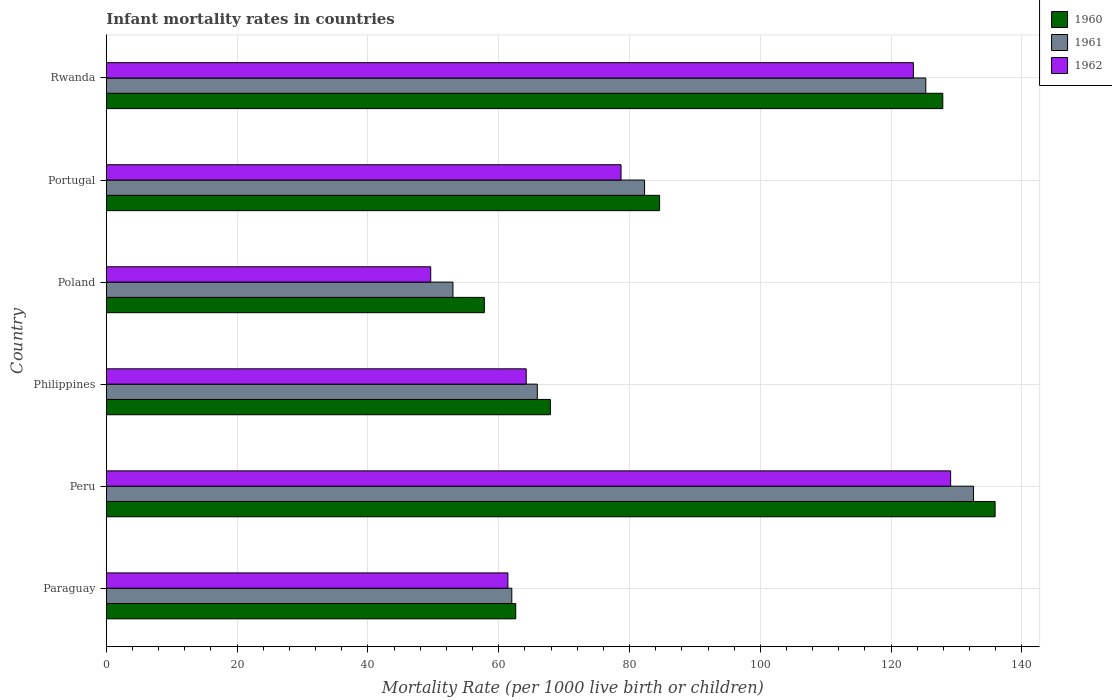How many different coloured bars are there?
Provide a short and direct response. 3. Are the number of bars per tick equal to the number of legend labels?
Offer a terse response. Yes. How many bars are there on the 2nd tick from the bottom?
Provide a succinct answer. 3. What is the infant mortality rate in 1960 in Philippines?
Your answer should be very brief. 67.9. Across all countries, what is the maximum infant mortality rate in 1962?
Make the answer very short. 129.1. Across all countries, what is the minimum infant mortality rate in 1960?
Give a very brief answer. 57.8. In which country was the infant mortality rate in 1962 maximum?
Make the answer very short. Peru. In which country was the infant mortality rate in 1962 minimum?
Provide a short and direct response. Poland. What is the total infant mortality rate in 1960 in the graph?
Provide a short and direct response. 536.7. What is the difference between the infant mortality rate in 1962 in Peru and that in Philippines?
Offer a terse response. 64.9. What is the difference between the infant mortality rate in 1961 in Poland and the infant mortality rate in 1962 in Portugal?
Keep it short and to the point. -25.7. What is the average infant mortality rate in 1960 per country?
Give a very brief answer. 89.45. What is the difference between the infant mortality rate in 1960 and infant mortality rate in 1961 in Paraguay?
Your response must be concise. 0.6. In how many countries, is the infant mortality rate in 1960 greater than 100 ?
Keep it short and to the point. 2. What is the ratio of the infant mortality rate in 1960 in Peru to that in Poland?
Your answer should be very brief. 2.35. Is the difference between the infant mortality rate in 1960 in Paraguay and Peru greater than the difference between the infant mortality rate in 1961 in Paraguay and Peru?
Your answer should be compact. No. What is the difference between the highest and the second highest infant mortality rate in 1961?
Give a very brief answer. 7.3. What is the difference between the highest and the lowest infant mortality rate in 1961?
Your answer should be compact. 79.6. Is the sum of the infant mortality rate in 1961 in Philippines and Poland greater than the maximum infant mortality rate in 1962 across all countries?
Give a very brief answer. No. What does the 1st bar from the bottom in Paraguay represents?
Your answer should be compact. 1960. Is it the case that in every country, the sum of the infant mortality rate in 1961 and infant mortality rate in 1962 is greater than the infant mortality rate in 1960?
Ensure brevity in your answer.  Yes. How many bars are there?
Ensure brevity in your answer.  18. Are all the bars in the graph horizontal?
Provide a succinct answer. Yes. How many countries are there in the graph?
Offer a terse response. 6. Are the values on the major ticks of X-axis written in scientific E-notation?
Provide a short and direct response. No. How are the legend labels stacked?
Your answer should be very brief. Vertical. What is the title of the graph?
Your answer should be very brief. Infant mortality rates in countries. What is the label or title of the X-axis?
Provide a succinct answer. Mortality Rate (per 1000 live birth or children). What is the Mortality Rate (per 1000 live birth or children) in 1960 in Paraguay?
Ensure brevity in your answer.  62.6. What is the Mortality Rate (per 1000 live birth or children) of 1962 in Paraguay?
Your response must be concise. 61.4. What is the Mortality Rate (per 1000 live birth or children) in 1960 in Peru?
Provide a short and direct response. 135.9. What is the Mortality Rate (per 1000 live birth or children) of 1961 in Peru?
Provide a succinct answer. 132.6. What is the Mortality Rate (per 1000 live birth or children) of 1962 in Peru?
Make the answer very short. 129.1. What is the Mortality Rate (per 1000 live birth or children) in 1960 in Philippines?
Your answer should be very brief. 67.9. What is the Mortality Rate (per 1000 live birth or children) of 1961 in Philippines?
Give a very brief answer. 65.9. What is the Mortality Rate (per 1000 live birth or children) in 1962 in Philippines?
Keep it short and to the point. 64.2. What is the Mortality Rate (per 1000 live birth or children) of 1960 in Poland?
Offer a very short reply. 57.8. What is the Mortality Rate (per 1000 live birth or children) in 1961 in Poland?
Your answer should be very brief. 53. What is the Mortality Rate (per 1000 live birth or children) of 1962 in Poland?
Provide a short and direct response. 49.6. What is the Mortality Rate (per 1000 live birth or children) of 1960 in Portugal?
Keep it short and to the point. 84.6. What is the Mortality Rate (per 1000 live birth or children) of 1961 in Portugal?
Give a very brief answer. 82.3. What is the Mortality Rate (per 1000 live birth or children) in 1962 in Portugal?
Your answer should be very brief. 78.7. What is the Mortality Rate (per 1000 live birth or children) in 1960 in Rwanda?
Make the answer very short. 127.9. What is the Mortality Rate (per 1000 live birth or children) in 1961 in Rwanda?
Offer a very short reply. 125.3. What is the Mortality Rate (per 1000 live birth or children) of 1962 in Rwanda?
Give a very brief answer. 123.4. Across all countries, what is the maximum Mortality Rate (per 1000 live birth or children) of 1960?
Your answer should be compact. 135.9. Across all countries, what is the maximum Mortality Rate (per 1000 live birth or children) of 1961?
Make the answer very short. 132.6. Across all countries, what is the maximum Mortality Rate (per 1000 live birth or children) of 1962?
Provide a succinct answer. 129.1. Across all countries, what is the minimum Mortality Rate (per 1000 live birth or children) of 1960?
Give a very brief answer. 57.8. Across all countries, what is the minimum Mortality Rate (per 1000 live birth or children) in 1962?
Your answer should be compact. 49.6. What is the total Mortality Rate (per 1000 live birth or children) in 1960 in the graph?
Give a very brief answer. 536.7. What is the total Mortality Rate (per 1000 live birth or children) of 1961 in the graph?
Your answer should be very brief. 521.1. What is the total Mortality Rate (per 1000 live birth or children) of 1962 in the graph?
Your response must be concise. 506.4. What is the difference between the Mortality Rate (per 1000 live birth or children) of 1960 in Paraguay and that in Peru?
Your answer should be compact. -73.3. What is the difference between the Mortality Rate (per 1000 live birth or children) in 1961 in Paraguay and that in Peru?
Provide a succinct answer. -70.6. What is the difference between the Mortality Rate (per 1000 live birth or children) in 1962 in Paraguay and that in Peru?
Make the answer very short. -67.7. What is the difference between the Mortality Rate (per 1000 live birth or children) of 1960 in Paraguay and that in Philippines?
Give a very brief answer. -5.3. What is the difference between the Mortality Rate (per 1000 live birth or children) of 1961 in Paraguay and that in Philippines?
Offer a very short reply. -3.9. What is the difference between the Mortality Rate (per 1000 live birth or children) in 1960 in Paraguay and that in Poland?
Your answer should be compact. 4.8. What is the difference between the Mortality Rate (per 1000 live birth or children) in 1960 in Paraguay and that in Portugal?
Make the answer very short. -22. What is the difference between the Mortality Rate (per 1000 live birth or children) in 1961 in Paraguay and that in Portugal?
Provide a short and direct response. -20.3. What is the difference between the Mortality Rate (per 1000 live birth or children) of 1962 in Paraguay and that in Portugal?
Your answer should be very brief. -17.3. What is the difference between the Mortality Rate (per 1000 live birth or children) in 1960 in Paraguay and that in Rwanda?
Offer a terse response. -65.3. What is the difference between the Mortality Rate (per 1000 live birth or children) in 1961 in Paraguay and that in Rwanda?
Offer a terse response. -63.3. What is the difference between the Mortality Rate (per 1000 live birth or children) in 1962 in Paraguay and that in Rwanda?
Your answer should be compact. -62. What is the difference between the Mortality Rate (per 1000 live birth or children) in 1960 in Peru and that in Philippines?
Make the answer very short. 68. What is the difference between the Mortality Rate (per 1000 live birth or children) of 1961 in Peru and that in Philippines?
Keep it short and to the point. 66.7. What is the difference between the Mortality Rate (per 1000 live birth or children) of 1962 in Peru and that in Philippines?
Give a very brief answer. 64.9. What is the difference between the Mortality Rate (per 1000 live birth or children) of 1960 in Peru and that in Poland?
Offer a very short reply. 78.1. What is the difference between the Mortality Rate (per 1000 live birth or children) in 1961 in Peru and that in Poland?
Offer a terse response. 79.6. What is the difference between the Mortality Rate (per 1000 live birth or children) of 1962 in Peru and that in Poland?
Your answer should be compact. 79.5. What is the difference between the Mortality Rate (per 1000 live birth or children) of 1960 in Peru and that in Portugal?
Offer a very short reply. 51.3. What is the difference between the Mortality Rate (per 1000 live birth or children) in 1961 in Peru and that in Portugal?
Offer a very short reply. 50.3. What is the difference between the Mortality Rate (per 1000 live birth or children) of 1962 in Peru and that in Portugal?
Make the answer very short. 50.4. What is the difference between the Mortality Rate (per 1000 live birth or children) in 1961 in Peru and that in Rwanda?
Your response must be concise. 7.3. What is the difference between the Mortality Rate (per 1000 live birth or children) of 1960 in Philippines and that in Poland?
Your answer should be compact. 10.1. What is the difference between the Mortality Rate (per 1000 live birth or children) in 1960 in Philippines and that in Portugal?
Provide a short and direct response. -16.7. What is the difference between the Mortality Rate (per 1000 live birth or children) of 1961 in Philippines and that in Portugal?
Provide a short and direct response. -16.4. What is the difference between the Mortality Rate (per 1000 live birth or children) of 1962 in Philippines and that in Portugal?
Give a very brief answer. -14.5. What is the difference between the Mortality Rate (per 1000 live birth or children) in 1960 in Philippines and that in Rwanda?
Your response must be concise. -60. What is the difference between the Mortality Rate (per 1000 live birth or children) in 1961 in Philippines and that in Rwanda?
Ensure brevity in your answer.  -59.4. What is the difference between the Mortality Rate (per 1000 live birth or children) of 1962 in Philippines and that in Rwanda?
Your answer should be very brief. -59.2. What is the difference between the Mortality Rate (per 1000 live birth or children) of 1960 in Poland and that in Portugal?
Your response must be concise. -26.8. What is the difference between the Mortality Rate (per 1000 live birth or children) in 1961 in Poland and that in Portugal?
Your answer should be very brief. -29.3. What is the difference between the Mortality Rate (per 1000 live birth or children) of 1962 in Poland and that in Portugal?
Your response must be concise. -29.1. What is the difference between the Mortality Rate (per 1000 live birth or children) of 1960 in Poland and that in Rwanda?
Your response must be concise. -70.1. What is the difference between the Mortality Rate (per 1000 live birth or children) in 1961 in Poland and that in Rwanda?
Your answer should be compact. -72.3. What is the difference between the Mortality Rate (per 1000 live birth or children) of 1962 in Poland and that in Rwanda?
Ensure brevity in your answer.  -73.8. What is the difference between the Mortality Rate (per 1000 live birth or children) in 1960 in Portugal and that in Rwanda?
Provide a succinct answer. -43.3. What is the difference between the Mortality Rate (per 1000 live birth or children) of 1961 in Portugal and that in Rwanda?
Offer a very short reply. -43. What is the difference between the Mortality Rate (per 1000 live birth or children) in 1962 in Portugal and that in Rwanda?
Make the answer very short. -44.7. What is the difference between the Mortality Rate (per 1000 live birth or children) of 1960 in Paraguay and the Mortality Rate (per 1000 live birth or children) of 1961 in Peru?
Your response must be concise. -70. What is the difference between the Mortality Rate (per 1000 live birth or children) of 1960 in Paraguay and the Mortality Rate (per 1000 live birth or children) of 1962 in Peru?
Your response must be concise. -66.5. What is the difference between the Mortality Rate (per 1000 live birth or children) of 1961 in Paraguay and the Mortality Rate (per 1000 live birth or children) of 1962 in Peru?
Give a very brief answer. -67.1. What is the difference between the Mortality Rate (per 1000 live birth or children) in 1961 in Paraguay and the Mortality Rate (per 1000 live birth or children) in 1962 in Philippines?
Ensure brevity in your answer.  -2.2. What is the difference between the Mortality Rate (per 1000 live birth or children) in 1960 in Paraguay and the Mortality Rate (per 1000 live birth or children) in 1961 in Poland?
Your response must be concise. 9.6. What is the difference between the Mortality Rate (per 1000 live birth or children) in 1960 in Paraguay and the Mortality Rate (per 1000 live birth or children) in 1961 in Portugal?
Keep it short and to the point. -19.7. What is the difference between the Mortality Rate (per 1000 live birth or children) in 1960 in Paraguay and the Mortality Rate (per 1000 live birth or children) in 1962 in Portugal?
Provide a succinct answer. -16.1. What is the difference between the Mortality Rate (per 1000 live birth or children) of 1961 in Paraguay and the Mortality Rate (per 1000 live birth or children) of 1962 in Portugal?
Give a very brief answer. -16.7. What is the difference between the Mortality Rate (per 1000 live birth or children) in 1960 in Paraguay and the Mortality Rate (per 1000 live birth or children) in 1961 in Rwanda?
Offer a terse response. -62.7. What is the difference between the Mortality Rate (per 1000 live birth or children) of 1960 in Paraguay and the Mortality Rate (per 1000 live birth or children) of 1962 in Rwanda?
Your answer should be very brief. -60.8. What is the difference between the Mortality Rate (per 1000 live birth or children) in 1961 in Paraguay and the Mortality Rate (per 1000 live birth or children) in 1962 in Rwanda?
Your response must be concise. -61.4. What is the difference between the Mortality Rate (per 1000 live birth or children) of 1960 in Peru and the Mortality Rate (per 1000 live birth or children) of 1961 in Philippines?
Ensure brevity in your answer.  70. What is the difference between the Mortality Rate (per 1000 live birth or children) in 1960 in Peru and the Mortality Rate (per 1000 live birth or children) in 1962 in Philippines?
Provide a succinct answer. 71.7. What is the difference between the Mortality Rate (per 1000 live birth or children) of 1961 in Peru and the Mortality Rate (per 1000 live birth or children) of 1962 in Philippines?
Give a very brief answer. 68.4. What is the difference between the Mortality Rate (per 1000 live birth or children) in 1960 in Peru and the Mortality Rate (per 1000 live birth or children) in 1961 in Poland?
Your answer should be compact. 82.9. What is the difference between the Mortality Rate (per 1000 live birth or children) in 1960 in Peru and the Mortality Rate (per 1000 live birth or children) in 1962 in Poland?
Give a very brief answer. 86.3. What is the difference between the Mortality Rate (per 1000 live birth or children) in 1960 in Peru and the Mortality Rate (per 1000 live birth or children) in 1961 in Portugal?
Give a very brief answer. 53.6. What is the difference between the Mortality Rate (per 1000 live birth or children) of 1960 in Peru and the Mortality Rate (per 1000 live birth or children) of 1962 in Portugal?
Offer a very short reply. 57.2. What is the difference between the Mortality Rate (per 1000 live birth or children) in 1961 in Peru and the Mortality Rate (per 1000 live birth or children) in 1962 in Portugal?
Your answer should be very brief. 53.9. What is the difference between the Mortality Rate (per 1000 live birth or children) in 1960 in Philippines and the Mortality Rate (per 1000 live birth or children) in 1962 in Poland?
Your response must be concise. 18.3. What is the difference between the Mortality Rate (per 1000 live birth or children) of 1961 in Philippines and the Mortality Rate (per 1000 live birth or children) of 1962 in Poland?
Make the answer very short. 16.3. What is the difference between the Mortality Rate (per 1000 live birth or children) of 1960 in Philippines and the Mortality Rate (per 1000 live birth or children) of 1961 in Portugal?
Offer a terse response. -14.4. What is the difference between the Mortality Rate (per 1000 live birth or children) of 1960 in Philippines and the Mortality Rate (per 1000 live birth or children) of 1962 in Portugal?
Provide a succinct answer. -10.8. What is the difference between the Mortality Rate (per 1000 live birth or children) in 1961 in Philippines and the Mortality Rate (per 1000 live birth or children) in 1962 in Portugal?
Provide a short and direct response. -12.8. What is the difference between the Mortality Rate (per 1000 live birth or children) in 1960 in Philippines and the Mortality Rate (per 1000 live birth or children) in 1961 in Rwanda?
Your response must be concise. -57.4. What is the difference between the Mortality Rate (per 1000 live birth or children) of 1960 in Philippines and the Mortality Rate (per 1000 live birth or children) of 1962 in Rwanda?
Make the answer very short. -55.5. What is the difference between the Mortality Rate (per 1000 live birth or children) in 1961 in Philippines and the Mortality Rate (per 1000 live birth or children) in 1962 in Rwanda?
Keep it short and to the point. -57.5. What is the difference between the Mortality Rate (per 1000 live birth or children) of 1960 in Poland and the Mortality Rate (per 1000 live birth or children) of 1961 in Portugal?
Give a very brief answer. -24.5. What is the difference between the Mortality Rate (per 1000 live birth or children) of 1960 in Poland and the Mortality Rate (per 1000 live birth or children) of 1962 in Portugal?
Your answer should be very brief. -20.9. What is the difference between the Mortality Rate (per 1000 live birth or children) of 1961 in Poland and the Mortality Rate (per 1000 live birth or children) of 1962 in Portugal?
Ensure brevity in your answer.  -25.7. What is the difference between the Mortality Rate (per 1000 live birth or children) of 1960 in Poland and the Mortality Rate (per 1000 live birth or children) of 1961 in Rwanda?
Provide a short and direct response. -67.5. What is the difference between the Mortality Rate (per 1000 live birth or children) in 1960 in Poland and the Mortality Rate (per 1000 live birth or children) in 1962 in Rwanda?
Offer a terse response. -65.6. What is the difference between the Mortality Rate (per 1000 live birth or children) in 1961 in Poland and the Mortality Rate (per 1000 live birth or children) in 1962 in Rwanda?
Your response must be concise. -70.4. What is the difference between the Mortality Rate (per 1000 live birth or children) in 1960 in Portugal and the Mortality Rate (per 1000 live birth or children) in 1961 in Rwanda?
Provide a short and direct response. -40.7. What is the difference between the Mortality Rate (per 1000 live birth or children) in 1960 in Portugal and the Mortality Rate (per 1000 live birth or children) in 1962 in Rwanda?
Give a very brief answer. -38.8. What is the difference between the Mortality Rate (per 1000 live birth or children) in 1961 in Portugal and the Mortality Rate (per 1000 live birth or children) in 1962 in Rwanda?
Provide a succinct answer. -41.1. What is the average Mortality Rate (per 1000 live birth or children) of 1960 per country?
Keep it short and to the point. 89.45. What is the average Mortality Rate (per 1000 live birth or children) in 1961 per country?
Ensure brevity in your answer.  86.85. What is the average Mortality Rate (per 1000 live birth or children) of 1962 per country?
Give a very brief answer. 84.4. What is the difference between the Mortality Rate (per 1000 live birth or children) of 1960 and Mortality Rate (per 1000 live birth or children) of 1961 in Paraguay?
Make the answer very short. 0.6. What is the difference between the Mortality Rate (per 1000 live birth or children) of 1961 and Mortality Rate (per 1000 live birth or children) of 1962 in Paraguay?
Provide a short and direct response. 0.6. What is the difference between the Mortality Rate (per 1000 live birth or children) in 1960 and Mortality Rate (per 1000 live birth or children) in 1962 in Peru?
Your answer should be compact. 6.8. What is the difference between the Mortality Rate (per 1000 live birth or children) in 1961 and Mortality Rate (per 1000 live birth or children) in 1962 in Peru?
Ensure brevity in your answer.  3.5. What is the difference between the Mortality Rate (per 1000 live birth or children) in 1960 and Mortality Rate (per 1000 live birth or children) in 1962 in Philippines?
Ensure brevity in your answer.  3.7. What is the difference between the Mortality Rate (per 1000 live birth or children) of 1961 and Mortality Rate (per 1000 live birth or children) of 1962 in Philippines?
Provide a succinct answer. 1.7. What is the difference between the Mortality Rate (per 1000 live birth or children) in 1960 and Mortality Rate (per 1000 live birth or children) in 1962 in Poland?
Keep it short and to the point. 8.2. What is the difference between the Mortality Rate (per 1000 live birth or children) of 1961 and Mortality Rate (per 1000 live birth or children) of 1962 in Poland?
Provide a short and direct response. 3.4. What is the difference between the Mortality Rate (per 1000 live birth or children) of 1960 and Mortality Rate (per 1000 live birth or children) of 1961 in Portugal?
Make the answer very short. 2.3. What is the difference between the Mortality Rate (per 1000 live birth or children) of 1960 and Mortality Rate (per 1000 live birth or children) of 1962 in Portugal?
Offer a terse response. 5.9. What is the difference between the Mortality Rate (per 1000 live birth or children) in 1961 and Mortality Rate (per 1000 live birth or children) in 1962 in Portugal?
Your answer should be very brief. 3.6. What is the ratio of the Mortality Rate (per 1000 live birth or children) in 1960 in Paraguay to that in Peru?
Ensure brevity in your answer.  0.46. What is the ratio of the Mortality Rate (per 1000 live birth or children) in 1961 in Paraguay to that in Peru?
Your response must be concise. 0.47. What is the ratio of the Mortality Rate (per 1000 live birth or children) of 1962 in Paraguay to that in Peru?
Offer a terse response. 0.48. What is the ratio of the Mortality Rate (per 1000 live birth or children) of 1960 in Paraguay to that in Philippines?
Give a very brief answer. 0.92. What is the ratio of the Mortality Rate (per 1000 live birth or children) in 1961 in Paraguay to that in Philippines?
Make the answer very short. 0.94. What is the ratio of the Mortality Rate (per 1000 live birth or children) of 1962 in Paraguay to that in Philippines?
Make the answer very short. 0.96. What is the ratio of the Mortality Rate (per 1000 live birth or children) of 1960 in Paraguay to that in Poland?
Offer a very short reply. 1.08. What is the ratio of the Mortality Rate (per 1000 live birth or children) in 1961 in Paraguay to that in Poland?
Provide a succinct answer. 1.17. What is the ratio of the Mortality Rate (per 1000 live birth or children) in 1962 in Paraguay to that in Poland?
Your answer should be compact. 1.24. What is the ratio of the Mortality Rate (per 1000 live birth or children) of 1960 in Paraguay to that in Portugal?
Offer a very short reply. 0.74. What is the ratio of the Mortality Rate (per 1000 live birth or children) in 1961 in Paraguay to that in Portugal?
Keep it short and to the point. 0.75. What is the ratio of the Mortality Rate (per 1000 live birth or children) in 1962 in Paraguay to that in Portugal?
Offer a terse response. 0.78. What is the ratio of the Mortality Rate (per 1000 live birth or children) of 1960 in Paraguay to that in Rwanda?
Your answer should be very brief. 0.49. What is the ratio of the Mortality Rate (per 1000 live birth or children) of 1961 in Paraguay to that in Rwanda?
Provide a short and direct response. 0.49. What is the ratio of the Mortality Rate (per 1000 live birth or children) of 1962 in Paraguay to that in Rwanda?
Your response must be concise. 0.5. What is the ratio of the Mortality Rate (per 1000 live birth or children) in 1960 in Peru to that in Philippines?
Your answer should be very brief. 2. What is the ratio of the Mortality Rate (per 1000 live birth or children) in 1961 in Peru to that in Philippines?
Provide a succinct answer. 2.01. What is the ratio of the Mortality Rate (per 1000 live birth or children) of 1962 in Peru to that in Philippines?
Offer a terse response. 2.01. What is the ratio of the Mortality Rate (per 1000 live birth or children) in 1960 in Peru to that in Poland?
Make the answer very short. 2.35. What is the ratio of the Mortality Rate (per 1000 live birth or children) in 1961 in Peru to that in Poland?
Keep it short and to the point. 2.5. What is the ratio of the Mortality Rate (per 1000 live birth or children) in 1962 in Peru to that in Poland?
Ensure brevity in your answer.  2.6. What is the ratio of the Mortality Rate (per 1000 live birth or children) of 1960 in Peru to that in Portugal?
Provide a short and direct response. 1.61. What is the ratio of the Mortality Rate (per 1000 live birth or children) of 1961 in Peru to that in Portugal?
Provide a short and direct response. 1.61. What is the ratio of the Mortality Rate (per 1000 live birth or children) of 1962 in Peru to that in Portugal?
Offer a terse response. 1.64. What is the ratio of the Mortality Rate (per 1000 live birth or children) in 1960 in Peru to that in Rwanda?
Your answer should be very brief. 1.06. What is the ratio of the Mortality Rate (per 1000 live birth or children) of 1961 in Peru to that in Rwanda?
Provide a short and direct response. 1.06. What is the ratio of the Mortality Rate (per 1000 live birth or children) of 1962 in Peru to that in Rwanda?
Offer a very short reply. 1.05. What is the ratio of the Mortality Rate (per 1000 live birth or children) in 1960 in Philippines to that in Poland?
Your response must be concise. 1.17. What is the ratio of the Mortality Rate (per 1000 live birth or children) of 1961 in Philippines to that in Poland?
Offer a very short reply. 1.24. What is the ratio of the Mortality Rate (per 1000 live birth or children) of 1962 in Philippines to that in Poland?
Provide a short and direct response. 1.29. What is the ratio of the Mortality Rate (per 1000 live birth or children) of 1960 in Philippines to that in Portugal?
Your answer should be very brief. 0.8. What is the ratio of the Mortality Rate (per 1000 live birth or children) in 1961 in Philippines to that in Portugal?
Ensure brevity in your answer.  0.8. What is the ratio of the Mortality Rate (per 1000 live birth or children) of 1962 in Philippines to that in Portugal?
Provide a short and direct response. 0.82. What is the ratio of the Mortality Rate (per 1000 live birth or children) of 1960 in Philippines to that in Rwanda?
Your answer should be very brief. 0.53. What is the ratio of the Mortality Rate (per 1000 live birth or children) in 1961 in Philippines to that in Rwanda?
Offer a very short reply. 0.53. What is the ratio of the Mortality Rate (per 1000 live birth or children) of 1962 in Philippines to that in Rwanda?
Keep it short and to the point. 0.52. What is the ratio of the Mortality Rate (per 1000 live birth or children) in 1960 in Poland to that in Portugal?
Your response must be concise. 0.68. What is the ratio of the Mortality Rate (per 1000 live birth or children) in 1961 in Poland to that in Portugal?
Offer a terse response. 0.64. What is the ratio of the Mortality Rate (per 1000 live birth or children) of 1962 in Poland to that in Portugal?
Provide a succinct answer. 0.63. What is the ratio of the Mortality Rate (per 1000 live birth or children) of 1960 in Poland to that in Rwanda?
Your answer should be very brief. 0.45. What is the ratio of the Mortality Rate (per 1000 live birth or children) in 1961 in Poland to that in Rwanda?
Your response must be concise. 0.42. What is the ratio of the Mortality Rate (per 1000 live birth or children) of 1962 in Poland to that in Rwanda?
Give a very brief answer. 0.4. What is the ratio of the Mortality Rate (per 1000 live birth or children) of 1960 in Portugal to that in Rwanda?
Give a very brief answer. 0.66. What is the ratio of the Mortality Rate (per 1000 live birth or children) in 1961 in Portugal to that in Rwanda?
Make the answer very short. 0.66. What is the ratio of the Mortality Rate (per 1000 live birth or children) in 1962 in Portugal to that in Rwanda?
Give a very brief answer. 0.64. What is the difference between the highest and the second highest Mortality Rate (per 1000 live birth or children) in 1960?
Provide a succinct answer. 8. What is the difference between the highest and the second highest Mortality Rate (per 1000 live birth or children) in 1962?
Offer a terse response. 5.7. What is the difference between the highest and the lowest Mortality Rate (per 1000 live birth or children) in 1960?
Offer a very short reply. 78.1. What is the difference between the highest and the lowest Mortality Rate (per 1000 live birth or children) in 1961?
Your answer should be very brief. 79.6. What is the difference between the highest and the lowest Mortality Rate (per 1000 live birth or children) of 1962?
Provide a short and direct response. 79.5. 